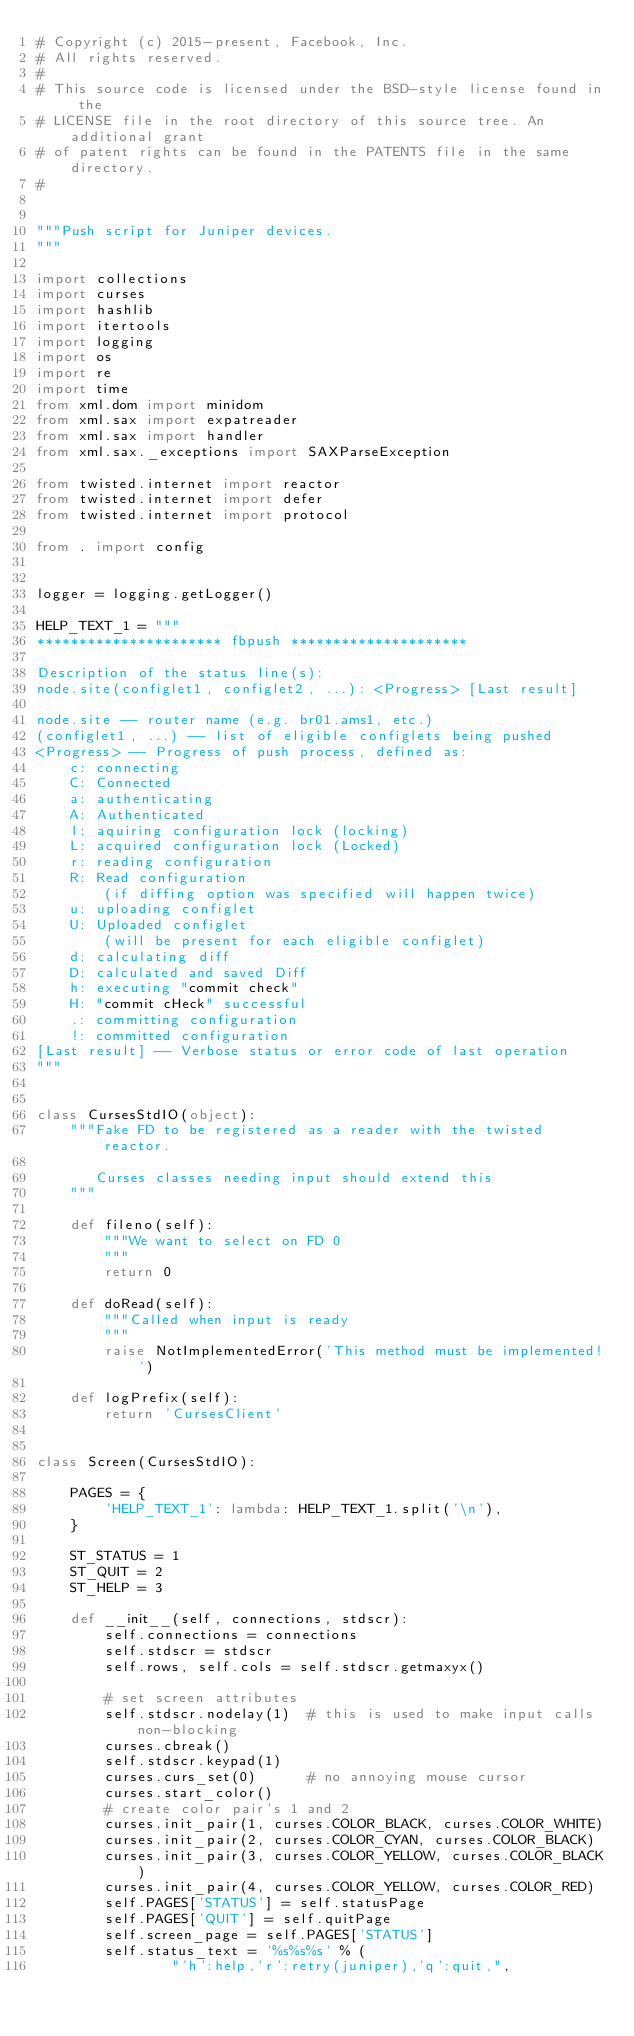<code> <loc_0><loc_0><loc_500><loc_500><_Python_># Copyright (c) 2015-present, Facebook, Inc.
# All rights reserved.
#
# This source code is licensed under the BSD-style license found in the
# LICENSE file in the root directory of this source tree. An additional grant
# of patent rights can be found in the PATENTS file in the same directory.
#


"""Push script for Juniper devices.
"""

import collections
import curses
import hashlib
import itertools
import logging
import os
import re
import time
from xml.dom import minidom
from xml.sax import expatreader
from xml.sax import handler
from xml.sax._exceptions import SAXParseException

from twisted.internet import reactor
from twisted.internet import defer
from twisted.internet import protocol

from . import config


logger = logging.getLogger()

HELP_TEXT_1 = """
********************** fbpush *********************

Description of the status line(s):
node.site(configlet1, configlet2, ...): <Progress> [Last result]

node.site -- router name (e.g. br01.ams1, etc.)
(configlet1, ...) -- list of eligible configlets being pushed
<Progress> -- Progress of push process, defined as:
    c: connecting
    C: Connected
    a: authenticating
    A: Authenticated
    l: aquiring configuration lock (locking)
    L: acquired configuration lock (Locked)
    r: reading configuration
    R: Read configuration
        (if diffing option was specified will happen twice)
    u: uploading configlet
    U: Uploaded configlet
        (will be present for each eligible configlet)
    d: calculating diff
    D: calculated and saved Diff
    h: executing "commit check"
    H: "commit cHeck" successful
    .: committing configuration
    !: committed configuration
[Last result] -- Verbose status or error code of last operation
"""


class CursesStdIO(object):
    """Fake FD to be registered as a reader with the twisted reactor.

       Curses classes needing input should extend this
    """

    def fileno(self):
        """We want to select on FD 0
        """
        return 0

    def doRead(self):
        """Called when input is ready
        """
        raise NotImplementedError('This method must be implemented!')

    def logPrefix(self):
        return 'CursesClient'


class Screen(CursesStdIO):

    PAGES = {
        'HELP_TEXT_1': lambda: HELP_TEXT_1.split('\n'),
    }

    ST_STATUS = 1
    ST_QUIT = 2
    ST_HELP = 3

    def __init__(self, connections, stdscr):
        self.connections = connections
        self.stdscr = stdscr
        self.rows, self.cols = self.stdscr.getmaxyx()

        # set screen attributes
        self.stdscr.nodelay(1)  # this is used to make input calls non-blocking
        curses.cbreak()
        self.stdscr.keypad(1)
        curses.curs_set(0)      # no annoying mouse cursor
        curses.start_color()
        # create color pair's 1 and 2
        curses.init_pair(1, curses.COLOR_BLACK, curses.COLOR_WHITE)
        curses.init_pair(2, curses.COLOR_CYAN, curses.COLOR_BLACK)
        curses.init_pair(3, curses.COLOR_YELLOW, curses.COLOR_BLACK)
        curses.init_pair(4, curses.COLOR_YELLOW, curses.COLOR_RED)
        self.PAGES['STATUS'] = self.statusPage
        self.PAGES['QUIT'] = self.quitPage
        self.screen_page = self.PAGES['STATUS']
        self.status_text = '%s%s%s' % (
                "'h':help,'r':retry(juniper),'q':quit,",</code> 